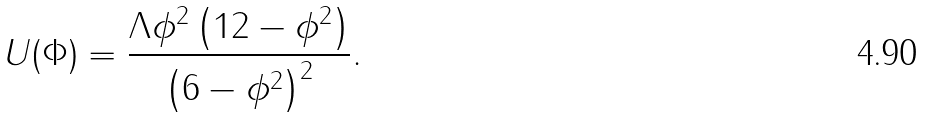<formula> <loc_0><loc_0><loc_500><loc_500>U ( \Phi ) = \frac { \Lambda \phi ^ { 2 } \left ( 1 2 - \phi ^ { 2 } \right ) } { \left ( 6 - \phi ^ { 2 } \right ) ^ { 2 } } .</formula> 